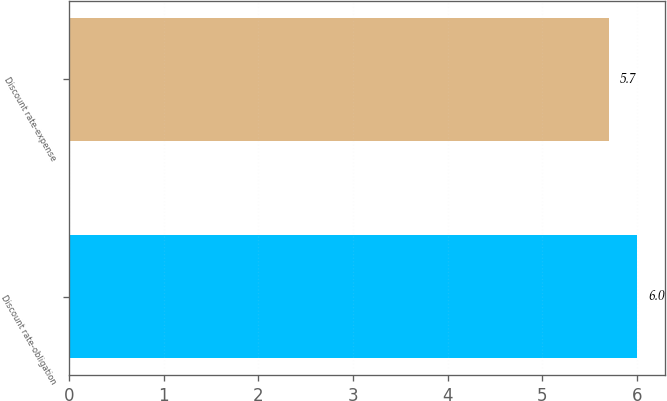Convert chart. <chart><loc_0><loc_0><loc_500><loc_500><bar_chart><fcel>Discount rate-obligation<fcel>Discount rate-expense<nl><fcel>6<fcel>5.7<nl></chart> 